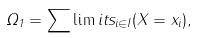<formula> <loc_0><loc_0><loc_500><loc_500>\Omega _ { 1 } = \sum \lim i t s _ { i \in I } ( X = x _ { i } ) ,</formula> 